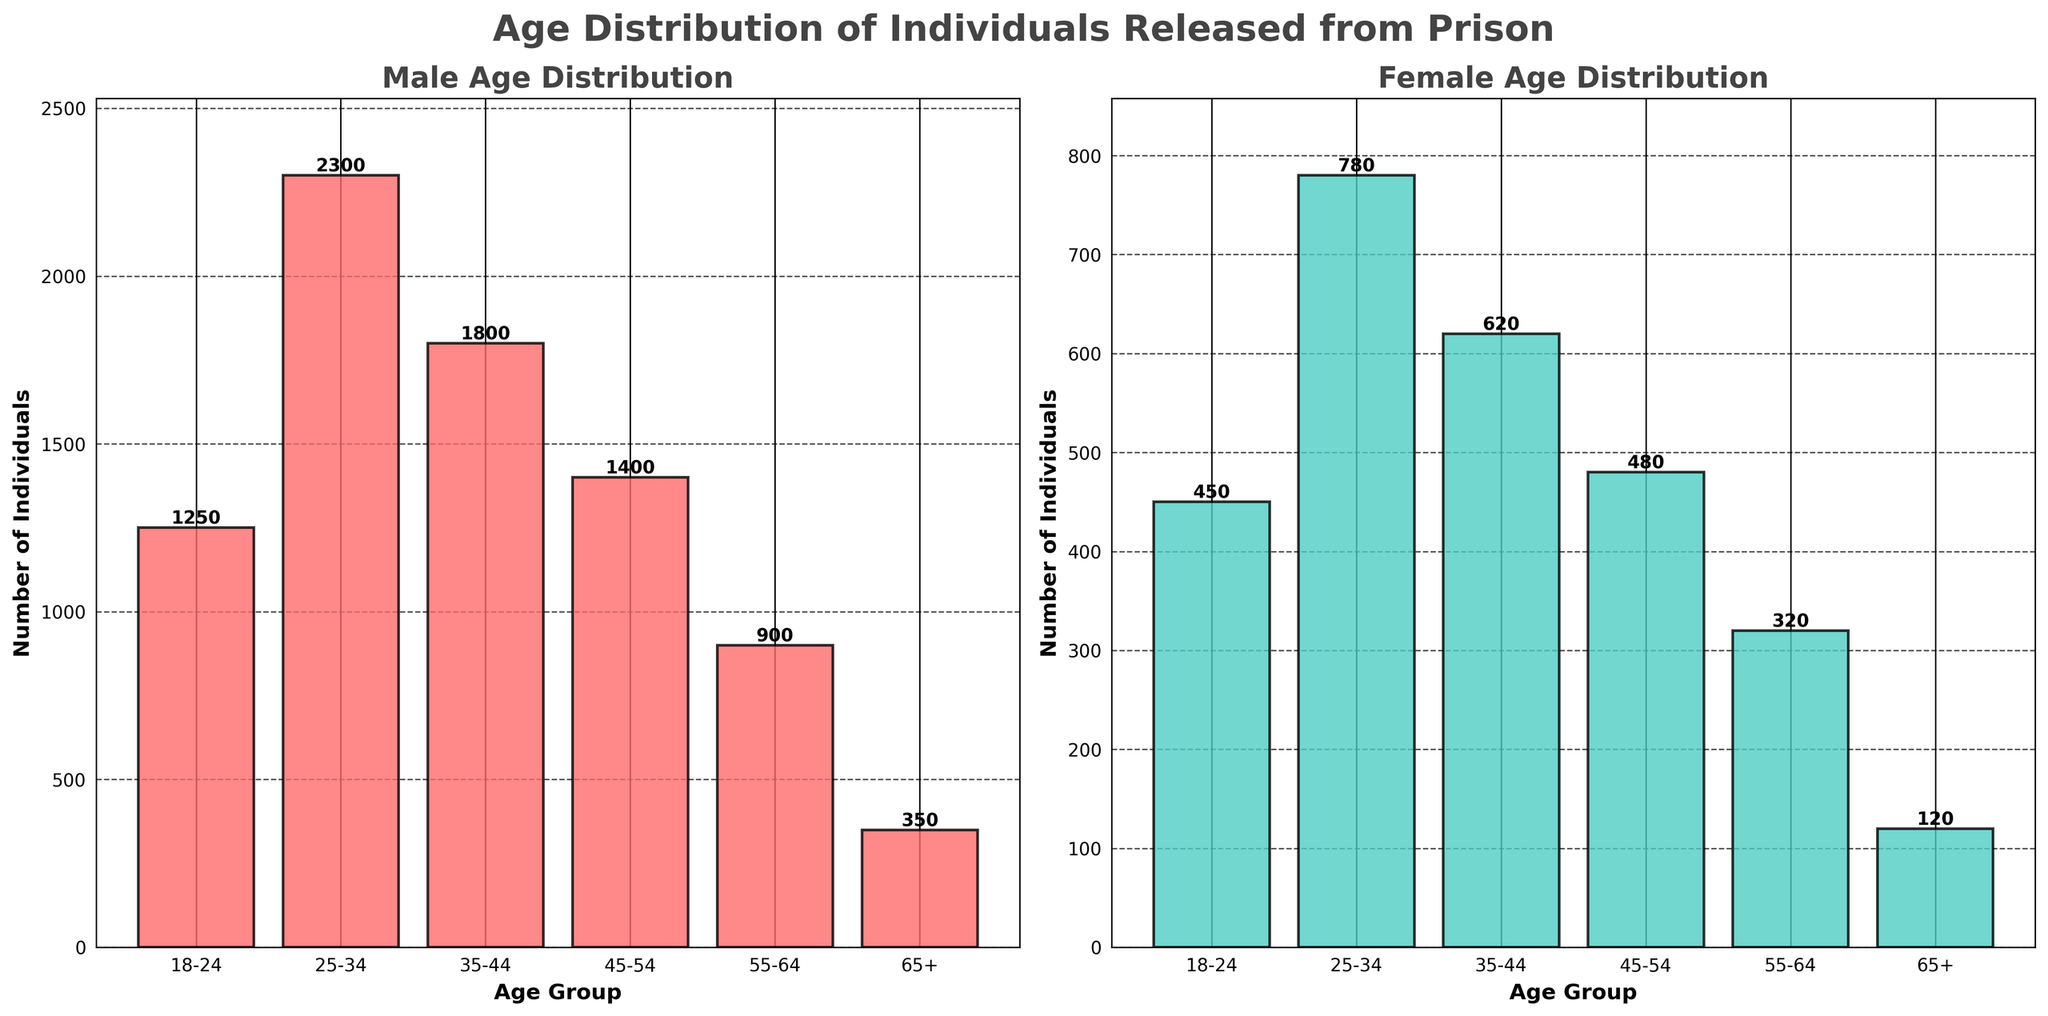What is the title of the figure? The title is located at the top center of the figure and reads "Age Distribution of Individuals Released from Prison"
Answer: Age Distribution of Individuals Released from Prison Which age group has the highest number of males released from prison? In the "Male Age Distribution" subplot, the tallest bar corresponds to the "25-34" age group with 2300 individuals.
Answer: 25-34 What is the total number of females released from prison in the age group of 35-44 and 45-54 combined? By looking at the "Female Age Distribution" subplot, we see 620 individuals in the 35-44 age group and 480 in the 45-54 age group. Summing these numbers gives 620 + 480 = 1100 individuals.
Answer: 1100 How many more males than females were released in the age group 18-24? Comparing the bar heights in the 18-24 age group for both subplots, males have 1250 and females have 450. The difference is 1250 - 450 = 800 individuals.
Answer: 800 Which age group has the lowest number of individuals for both genders? By examining all bars in both subplots, the 65+ age group has the lowest count across both, with 350 males and 120 females.
Answer: 65+ What is the ratio of males to females released in the 25-34 age group? From the figure, 2300 males and 780 females are released in the 25-34 age group. The ratio can be calculated as 2300 / 780 ≈ 2.95.
Answer: 2.95 Compare the number of individuals released in the 55-64 age group between genders and state which gender has more and by how much. From the subplots, the number of males in 55-64 is 900, while females are 320. Males exceed females by 900 - 320 = 580 individuals.
Answer: Males have 580 more than females What trends can you observe about the age distribution of released males compared to females? Observing both subplots, males show a peak in the 25-34 age group and generally higher counts in all age groups compared to females, with both distributions declining with age.
Answer: Males generally have higher counts in each age group, peaking in the 25-34 age group Which two age groups have the combined smallest number of individuals released for females? In the Females subplot, the smallest counts are in the 55-64 and 65+ age groups, with 320 and 120 respectively. Their combined total is 320 + 120 = 440 individuals.
Answer: 55-64 and 65+ What is the percentage of males aged 35-44 compared to the total number of males released? The number of males aged 35-44 is 1800. The total number of males released is 1250 + 2300 + 1800 + 1400 + 900 + 350 = 8000. The percentage is (1800 / 8000) * 100 ≈ 22.5%.
Answer: 22.5% 